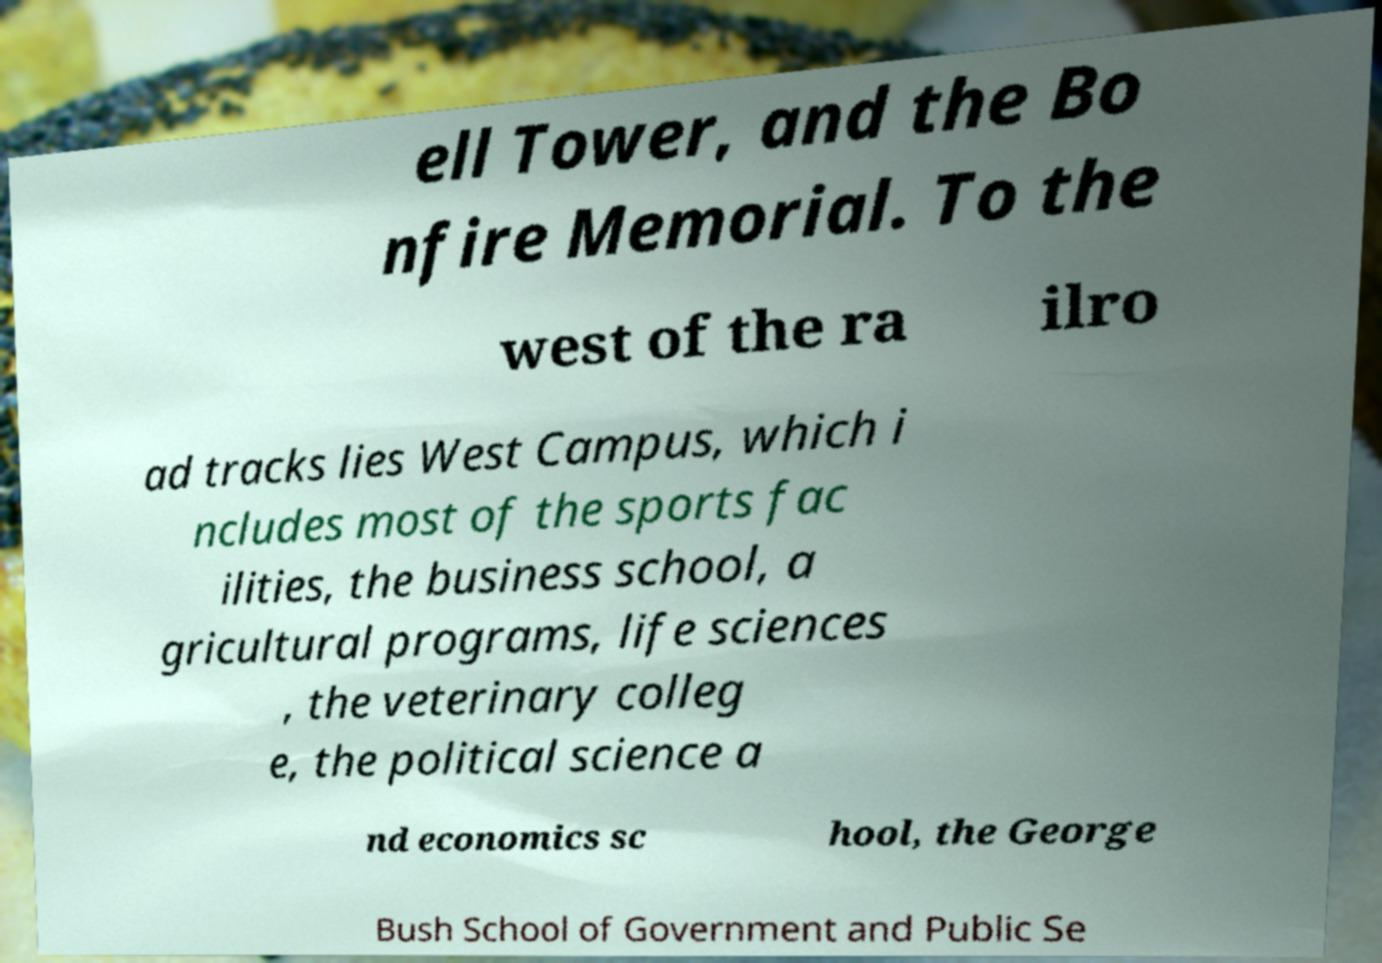Can you read and provide the text displayed in the image?This photo seems to have some interesting text. Can you extract and type it out for me? ell Tower, and the Bo nfire Memorial. To the west of the ra ilro ad tracks lies West Campus, which i ncludes most of the sports fac ilities, the business school, a gricultural programs, life sciences , the veterinary colleg e, the political science a nd economics sc hool, the George Bush School of Government and Public Se 